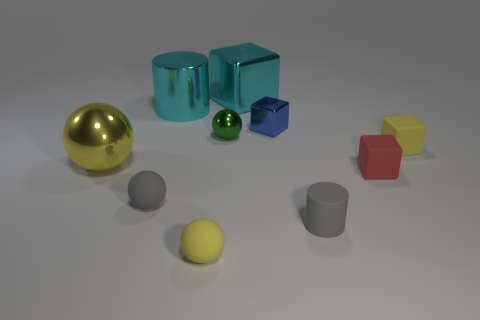Subtract all small yellow blocks. How many blocks are left? 3 Subtract all yellow cylinders. How many yellow balls are left? 2 Subtract all green balls. How many balls are left? 3 Subtract all cylinders. How many objects are left? 8 Subtract 2 balls. How many balls are left? 2 Subtract all gray cylinders. Subtract all green cubes. How many cylinders are left? 1 Subtract all gray spheres. Subtract all big cyan shiny blocks. How many objects are left? 8 Add 3 tiny green balls. How many tiny green balls are left? 4 Add 4 yellow rubber cylinders. How many yellow rubber cylinders exist? 4 Subtract 0 blue cylinders. How many objects are left? 10 